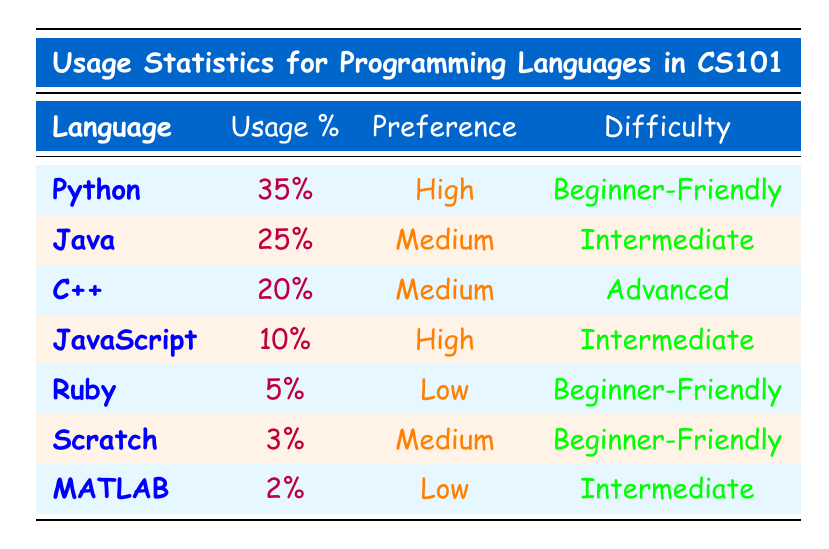What is the programming language with the highest usage percentage? The table shows that Python has the highest usage percentage at 35%.
Answer: Python What is the usage percentage of JavaScript? The table lists JavaScript with a usage percentage of 10%.
Answer: 10% Are there more students who prefer Python or Java? According to the table, Python has a preference of "High," while Java has "Medium." Therefore, more students prefer Python.
Answer: Yes What is the difference in usage percentage between Python and C++? Python has a usage percentage of 35%, and C++ has 20%. The difference is 35% - 20% = 15%.
Answer: 15% Which programming language has the lowest usage percentage? The table indicates that MATLAB has the lowest usage percentage at 2%.
Answer: MATLAB If we sum the usage percentages of all programming languages, what is the total? The sum of the usage percentages in the table is (35% + 25% + 20% + 10% + 5% + 3% + 2%) = 100%.
Answer: 100% Is Ruby preferred more than Scratch by students? Ruby has a preference of "Low," while Scratch has "Medium," indicating that Scratch is preferred more by students.
Answer: No What is the highest difficulty level among the languages listed? The table shows that C++ is labeled as "Advanced," which is the highest difficulty level among the listed languages.
Answer: C++ How many programming languages have a "Beginner-Friendly" difficulty level? Python, Ruby, and Scratch are all categorized as "Beginner-Friendly," amounting to three languages.
Answer: 3 Which programming languages have a medium preference? The table lists Java, C++, and Scratch as having "Medium" preference.
Answer: Java, C++, Scratch 